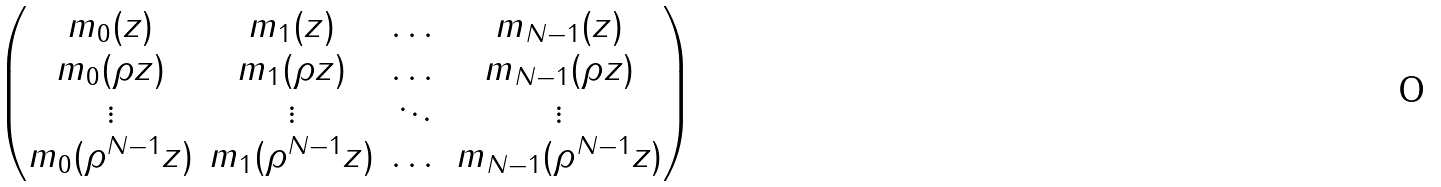Convert formula to latex. <formula><loc_0><loc_0><loc_500><loc_500>\begin{pmatrix} m _ { 0 } ( z ) & m _ { 1 } ( z ) & \dots & m _ { N - 1 } ( z ) \\ m _ { 0 } ( \rho z ) & m _ { 1 } ( \rho z ) & \dots & m _ { N - 1 } ( \rho z ) \\ \vdots & \vdots & \ddots & \vdots \\ m _ { 0 } ( \rho ^ { N - 1 } z ) & m _ { 1 } ( \rho ^ { N - 1 } z ) & \dots & m _ { N - 1 } ( \rho ^ { N - 1 } z ) \end{pmatrix}</formula> 